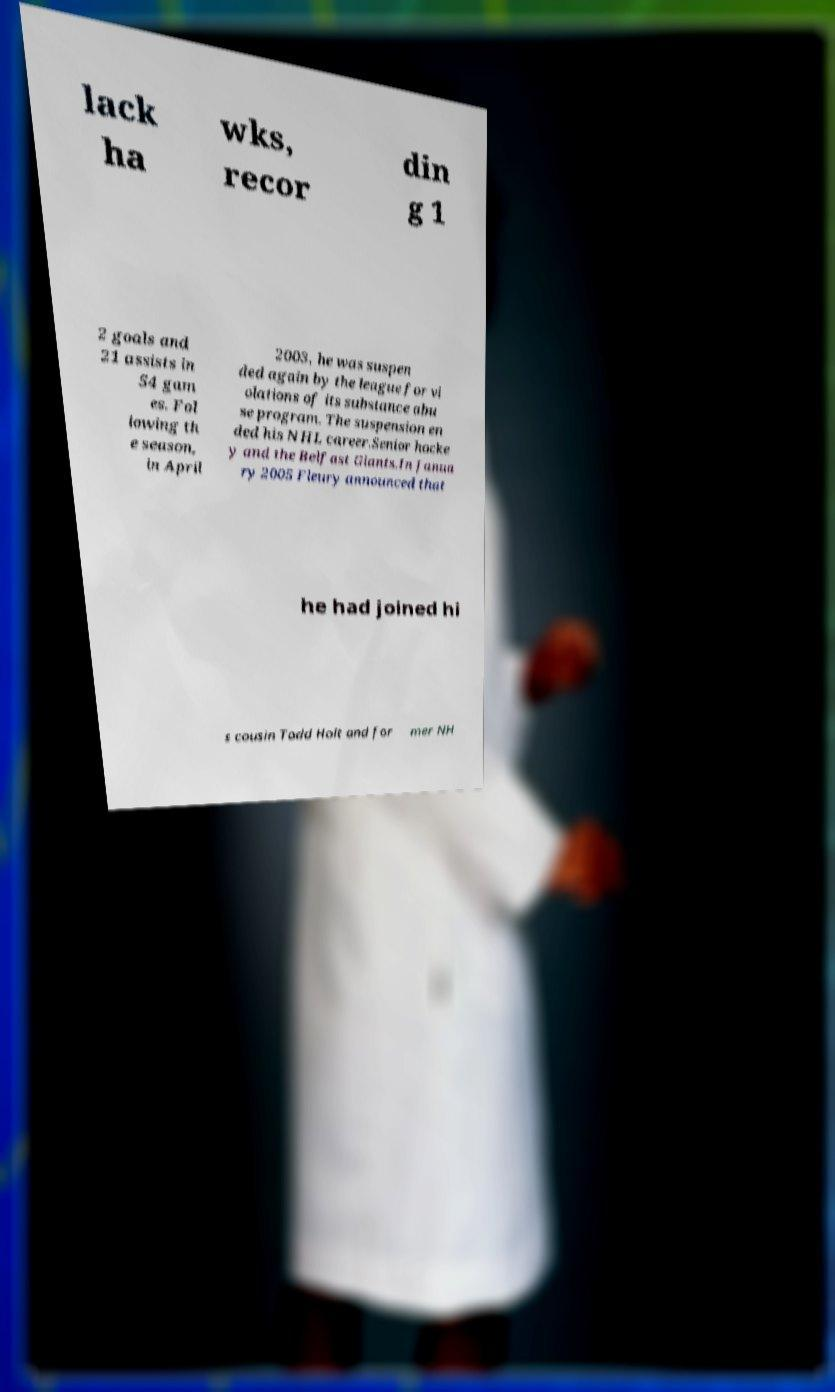What messages or text are displayed in this image? I need them in a readable, typed format. lack ha wks, recor din g 1 2 goals and 21 assists in 54 gam es. Fol lowing th e season, in April 2003, he was suspen ded again by the league for vi olations of its substance abu se program. The suspension en ded his NHL career.Senior hocke y and the Belfast Giants.In Janua ry 2005 Fleury announced that he had joined hi s cousin Todd Holt and for mer NH 